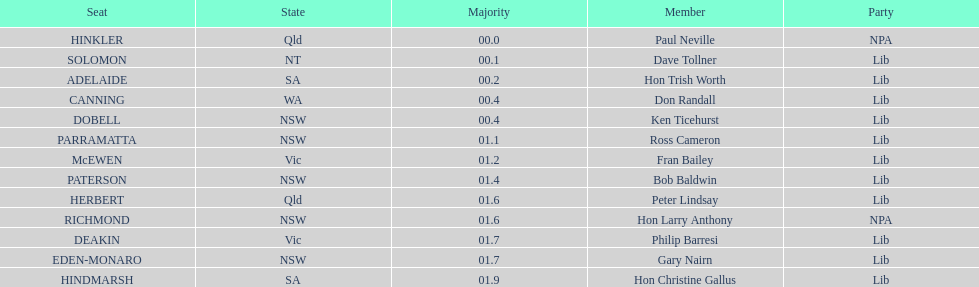Who appears before don randall in the list? Hon Trish Worth. 